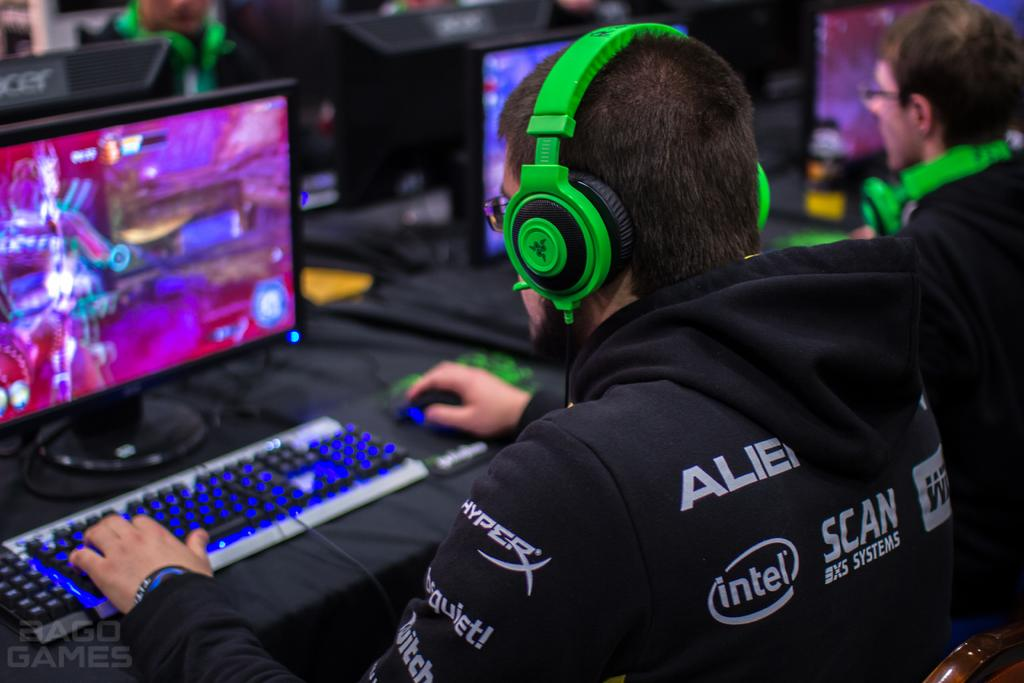Provide a one-sentence caption for the provided image. A person wearing green headphones and a black sweatshirt with Intel written on it. 